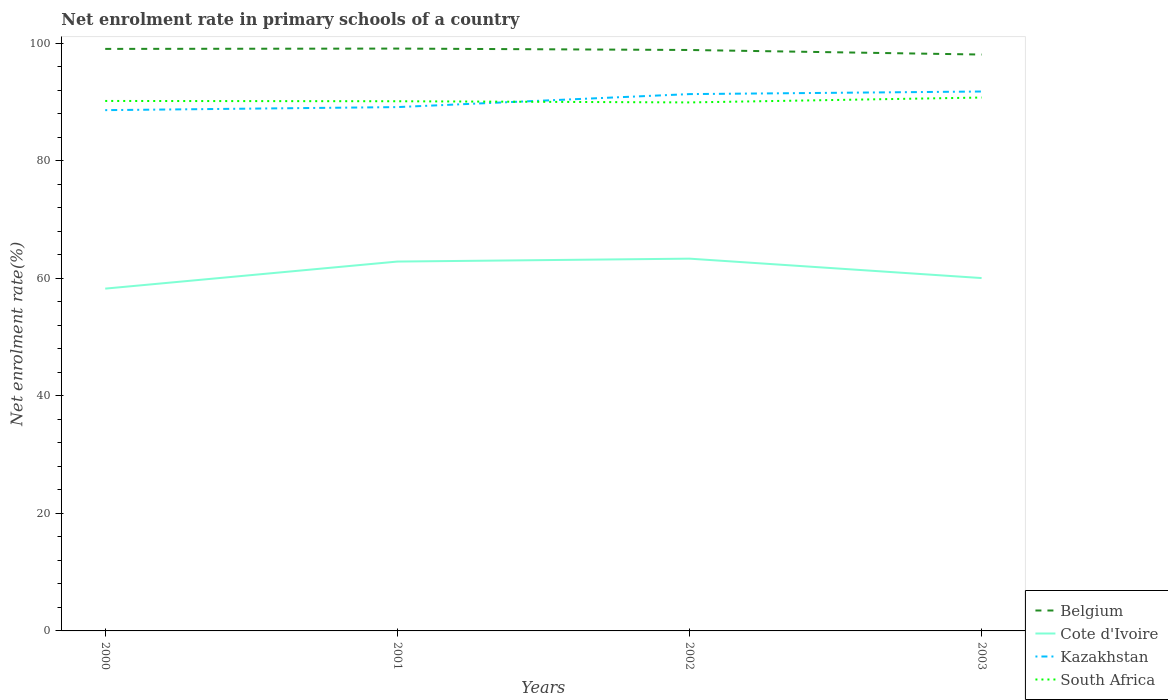How many different coloured lines are there?
Offer a terse response. 4. Is the number of lines equal to the number of legend labels?
Your answer should be compact. Yes. Across all years, what is the maximum net enrolment rate in primary schools in South Africa?
Keep it short and to the point. 89.95. What is the total net enrolment rate in primary schools in Belgium in the graph?
Provide a succinct answer. 0.96. What is the difference between the highest and the second highest net enrolment rate in primary schools in South Africa?
Your answer should be very brief. 0.83. How many years are there in the graph?
Ensure brevity in your answer.  4. Does the graph contain any zero values?
Make the answer very short. No. Does the graph contain grids?
Your answer should be very brief. No. What is the title of the graph?
Keep it short and to the point. Net enrolment rate in primary schools of a country. Does "Burkina Faso" appear as one of the legend labels in the graph?
Ensure brevity in your answer.  No. What is the label or title of the Y-axis?
Keep it short and to the point. Net enrolment rate(%). What is the Net enrolment rate(%) of Belgium in 2000?
Keep it short and to the point. 99.06. What is the Net enrolment rate(%) of Cote d'Ivoire in 2000?
Your answer should be very brief. 58.26. What is the Net enrolment rate(%) in Kazakhstan in 2000?
Offer a very short reply. 88.63. What is the Net enrolment rate(%) of South Africa in 2000?
Provide a short and direct response. 90.2. What is the Net enrolment rate(%) of Belgium in 2001?
Ensure brevity in your answer.  99.11. What is the Net enrolment rate(%) of Cote d'Ivoire in 2001?
Offer a very short reply. 62.86. What is the Net enrolment rate(%) of Kazakhstan in 2001?
Your answer should be very brief. 89.15. What is the Net enrolment rate(%) of South Africa in 2001?
Your answer should be compact. 90.15. What is the Net enrolment rate(%) in Belgium in 2002?
Offer a very short reply. 98.87. What is the Net enrolment rate(%) in Cote d'Ivoire in 2002?
Provide a succinct answer. 63.36. What is the Net enrolment rate(%) of Kazakhstan in 2002?
Give a very brief answer. 91.36. What is the Net enrolment rate(%) of South Africa in 2002?
Ensure brevity in your answer.  89.95. What is the Net enrolment rate(%) of Belgium in 2003?
Keep it short and to the point. 98.09. What is the Net enrolment rate(%) in Cote d'Ivoire in 2003?
Ensure brevity in your answer.  60.05. What is the Net enrolment rate(%) of Kazakhstan in 2003?
Provide a succinct answer. 91.81. What is the Net enrolment rate(%) of South Africa in 2003?
Offer a very short reply. 90.78. Across all years, what is the maximum Net enrolment rate(%) of Belgium?
Ensure brevity in your answer.  99.11. Across all years, what is the maximum Net enrolment rate(%) in Cote d'Ivoire?
Make the answer very short. 63.36. Across all years, what is the maximum Net enrolment rate(%) of Kazakhstan?
Provide a short and direct response. 91.81. Across all years, what is the maximum Net enrolment rate(%) in South Africa?
Your answer should be compact. 90.78. Across all years, what is the minimum Net enrolment rate(%) of Belgium?
Your answer should be compact. 98.09. Across all years, what is the minimum Net enrolment rate(%) in Cote d'Ivoire?
Ensure brevity in your answer.  58.26. Across all years, what is the minimum Net enrolment rate(%) in Kazakhstan?
Your response must be concise. 88.63. Across all years, what is the minimum Net enrolment rate(%) in South Africa?
Give a very brief answer. 89.95. What is the total Net enrolment rate(%) in Belgium in the graph?
Provide a short and direct response. 395.13. What is the total Net enrolment rate(%) of Cote d'Ivoire in the graph?
Provide a short and direct response. 244.53. What is the total Net enrolment rate(%) of Kazakhstan in the graph?
Your answer should be very brief. 360.95. What is the total Net enrolment rate(%) in South Africa in the graph?
Provide a short and direct response. 361.07. What is the difference between the Net enrolment rate(%) of Belgium in 2000 and that in 2001?
Make the answer very short. -0.06. What is the difference between the Net enrolment rate(%) in Cote d'Ivoire in 2000 and that in 2001?
Keep it short and to the point. -4.6. What is the difference between the Net enrolment rate(%) in Kazakhstan in 2000 and that in 2001?
Your answer should be very brief. -0.52. What is the difference between the Net enrolment rate(%) of South Africa in 2000 and that in 2001?
Your response must be concise. 0.05. What is the difference between the Net enrolment rate(%) of Belgium in 2000 and that in 2002?
Offer a terse response. 0.18. What is the difference between the Net enrolment rate(%) in Cote d'Ivoire in 2000 and that in 2002?
Ensure brevity in your answer.  -5.1. What is the difference between the Net enrolment rate(%) in Kazakhstan in 2000 and that in 2002?
Your response must be concise. -2.73. What is the difference between the Net enrolment rate(%) in South Africa in 2000 and that in 2002?
Offer a terse response. 0.25. What is the difference between the Net enrolment rate(%) in Belgium in 2000 and that in 2003?
Ensure brevity in your answer.  0.96. What is the difference between the Net enrolment rate(%) in Cote d'Ivoire in 2000 and that in 2003?
Your answer should be compact. -1.8. What is the difference between the Net enrolment rate(%) in Kazakhstan in 2000 and that in 2003?
Provide a succinct answer. -3.17. What is the difference between the Net enrolment rate(%) in South Africa in 2000 and that in 2003?
Provide a short and direct response. -0.58. What is the difference between the Net enrolment rate(%) in Belgium in 2001 and that in 2002?
Offer a terse response. 0.24. What is the difference between the Net enrolment rate(%) in Cote d'Ivoire in 2001 and that in 2002?
Provide a succinct answer. -0.5. What is the difference between the Net enrolment rate(%) of Kazakhstan in 2001 and that in 2002?
Offer a very short reply. -2.21. What is the difference between the Net enrolment rate(%) of South Africa in 2001 and that in 2002?
Make the answer very short. 0.2. What is the difference between the Net enrolment rate(%) of Belgium in 2001 and that in 2003?
Give a very brief answer. 1.02. What is the difference between the Net enrolment rate(%) of Cote d'Ivoire in 2001 and that in 2003?
Give a very brief answer. 2.81. What is the difference between the Net enrolment rate(%) of Kazakhstan in 2001 and that in 2003?
Provide a short and direct response. -2.65. What is the difference between the Net enrolment rate(%) of South Africa in 2001 and that in 2003?
Your response must be concise. -0.63. What is the difference between the Net enrolment rate(%) in Belgium in 2002 and that in 2003?
Give a very brief answer. 0.78. What is the difference between the Net enrolment rate(%) of Cote d'Ivoire in 2002 and that in 2003?
Offer a terse response. 3.3. What is the difference between the Net enrolment rate(%) in Kazakhstan in 2002 and that in 2003?
Your answer should be compact. -0.44. What is the difference between the Net enrolment rate(%) of South Africa in 2002 and that in 2003?
Ensure brevity in your answer.  -0.83. What is the difference between the Net enrolment rate(%) in Belgium in 2000 and the Net enrolment rate(%) in Cote d'Ivoire in 2001?
Offer a terse response. 36.19. What is the difference between the Net enrolment rate(%) of Belgium in 2000 and the Net enrolment rate(%) of Kazakhstan in 2001?
Ensure brevity in your answer.  9.9. What is the difference between the Net enrolment rate(%) of Belgium in 2000 and the Net enrolment rate(%) of South Africa in 2001?
Make the answer very short. 8.91. What is the difference between the Net enrolment rate(%) of Cote d'Ivoire in 2000 and the Net enrolment rate(%) of Kazakhstan in 2001?
Provide a short and direct response. -30.89. What is the difference between the Net enrolment rate(%) of Cote d'Ivoire in 2000 and the Net enrolment rate(%) of South Africa in 2001?
Ensure brevity in your answer.  -31.89. What is the difference between the Net enrolment rate(%) in Kazakhstan in 2000 and the Net enrolment rate(%) in South Africa in 2001?
Your answer should be very brief. -1.52. What is the difference between the Net enrolment rate(%) of Belgium in 2000 and the Net enrolment rate(%) of Cote d'Ivoire in 2002?
Your answer should be compact. 35.7. What is the difference between the Net enrolment rate(%) in Belgium in 2000 and the Net enrolment rate(%) in Kazakhstan in 2002?
Ensure brevity in your answer.  7.69. What is the difference between the Net enrolment rate(%) in Belgium in 2000 and the Net enrolment rate(%) in South Africa in 2002?
Keep it short and to the point. 9.11. What is the difference between the Net enrolment rate(%) of Cote d'Ivoire in 2000 and the Net enrolment rate(%) of Kazakhstan in 2002?
Your answer should be compact. -33.11. What is the difference between the Net enrolment rate(%) in Cote d'Ivoire in 2000 and the Net enrolment rate(%) in South Africa in 2002?
Ensure brevity in your answer.  -31.69. What is the difference between the Net enrolment rate(%) in Kazakhstan in 2000 and the Net enrolment rate(%) in South Africa in 2002?
Your answer should be compact. -1.31. What is the difference between the Net enrolment rate(%) of Belgium in 2000 and the Net enrolment rate(%) of Cote d'Ivoire in 2003?
Ensure brevity in your answer.  39. What is the difference between the Net enrolment rate(%) in Belgium in 2000 and the Net enrolment rate(%) in Kazakhstan in 2003?
Offer a terse response. 7.25. What is the difference between the Net enrolment rate(%) of Belgium in 2000 and the Net enrolment rate(%) of South Africa in 2003?
Provide a succinct answer. 8.28. What is the difference between the Net enrolment rate(%) of Cote d'Ivoire in 2000 and the Net enrolment rate(%) of Kazakhstan in 2003?
Provide a succinct answer. -33.55. What is the difference between the Net enrolment rate(%) in Cote d'Ivoire in 2000 and the Net enrolment rate(%) in South Africa in 2003?
Make the answer very short. -32.52. What is the difference between the Net enrolment rate(%) of Kazakhstan in 2000 and the Net enrolment rate(%) of South Africa in 2003?
Your answer should be very brief. -2.15. What is the difference between the Net enrolment rate(%) of Belgium in 2001 and the Net enrolment rate(%) of Cote d'Ivoire in 2002?
Your answer should be compact. 35.75. What is the difference between the Net enrolment rate(%) in Belgium in 2001 and the Net enrolment rate(%) in Kazakhstan in 2002?
Provide a short and direct response. 7.75. What is the difference between the Net enrolment rate(%) of Belgium in 2001 and the Net enrolment rate(%) of South Africa in 2002?
Give a very brief answer. 9.16. What is the difference between the Net enrolment rate(%) of Cote d'Ivoire in 2001 and the Net enrolment rate(%) of Kazakhstan in 2002?
Provide a succinct answer. -28.5. What is the difference between the Net enrolment rate(%) of Cote d'Ivoire in 2001 and the Net enrolment rate(%) of South Africa in 2002?
Your answer should be very brief. -27.08. What is the difference between the Net enrolment rate(%) in Kazakhstan in 2001 and the Net enrolment rate(%) in South Africa in 2002?
Your answer should be compact. -0.8. What is the difference between the Net enrolment rate(%) in Belgium in 2001 and the Net enrolment rate(%) in Cote d'Ivoire in 2003?
Keep it short and to the point. 39.06. What is the difference between the Net enrolment rate(%) of Belgium in 2001 and the Net enrolment rate(%) of Kazakhstan in 2003?
Your answer should be very brief. 7.31. What is the difference between the Net enrolment rate(%) of Belgium in 2001 and the Net enrolment rate(%) of South Africa in 2003?
Keep it short and to the point. 8.33. What is the difference between the Net enrolment rate(%) of Cote d'Ivoire in 2001 and the Net enrolment rate(%) of Kazakhstan in 2003?
Provide a succinct answer. -28.94. What is the difference between the Net enrolment rate(%) in Cote d'Ivoire in 2001 and the Net enrolment rate(%) in South Africa in 2003?
Offer a terse response. -27.92. What is the difference between the Net enrolment rate(%) of Kazakhstan in 2001 and the Net enrolment rate(%) of South Africa in 2003?
Keep it short and to the point. -1.63. What is the difference between the Net enrolment rate(%) of Belgium in 2002 and the Net enrolment rate(%) of Cote d'Ivoire in 2003?
Your response must be concise. 38.82. What is the difference between the Net enrolment rate(%) in Belgium in 2002 and the Net enrolment rate(%) in Kazakhstan in 2003?
Offer a terse response. 7.07. What is the difference between the Net enrolment rate(%) in Belgium in 2002 and the Net enrolment rate(%) in South Africa in 2003?
Give a very brief answer. 8.09. What is the difference between the Net enrolment rate(%) in Cote d'Ivoire in 2002 and the Net enrolment rate(%) in Kazakhstan in 2003?
Give a very brief answer. -28.45. What is the difference between the Net enrolment rate(%) in Cote d'Ivoire in 2002 and the Net enrolment rate(%) in South Africa in 2003?
Your answer should be very brief. -27.42. What is the difference between the Net enrolment rate(%) of Kazakhstan in 2002 and the Net enrolment rate(%) of South Africa in 2003?
Make the answer very short. 0.59. What is the average Net enrolment rate(%) in Belgium per year?
Offer a very short reply. 98.78. What is the average Net enrolment rate(%) of Cote d'Ivoire per year?
Keep it short and to the point. 61.13. What is the average Net enrolment rate(%) in Kazakhstan per year?
Give a very brief answer. 90.24. What is the average Net enrolment rate(%) in South Africa per year?
Offer a terse response. 90.27. In the year 2000, what is the difference between the Net enrolment rate(%) in Belgium and Net enrolment rate(%) in Cote d'Ivoire?
Your answer should be very brief. 40.8. In the year 2000, what is the difference between the Net enrolment rate(%) in Belgium and Net enrolment rate(%) in Kazakhstan?
Your answer should be compact. 10.42. In the year 2000, what is the difference between the Net enrolment rate(%) in Belgium and Net enrolment rate(%) in South Africa?
Provide a succinct answer. 8.86. In the year 2000, what is the difference between the Net enrolment rate(%) in Cote d'Ivoire and Net enrolment rate(%) in Kazakhstan?
Your response must be concise. -30.38. In the year 2000, what is the difference between the Net enrolment rate(%) in Cote d'Ivoire and Net enrolment rate(%) in South Africa?
Offer a very short reply. -31.94. In the year 2000, what is the difference between the Net enrolment rate(%) in Kazakhstan and Net enrolment rate(%) in South Africa?
Provide a succinct answer. -1.56. In the year 2001, what is the difference between the Net enrolment rate(%) of Belgium and Net enrolment rate(%) of Cote d'Ivoire?
Ensure brevity in your answer.  36.25. In the year 2001, what is the difference between the Net enrolment rate(%) in Belgium and Net enrolment rate(%) in Kazakhstan?
Offer a terse response. 9.96. In the year 2001, what is the difference between the Net enrolment rate(%) in Belgium and Net enrolment rate(%) in South Africa?
Your answer should be very brief. 8.96. In the year 2001, what is the difference between the Net enrolment rate(%) in Cote d'Ivoire and Net enrolment rate(%) in Kazakhstan?
Give a very brief answer. -26.29. In the year 2001, what is the difference between the Net enrolment rate(%) in Cote d'Ivoire and Net enrolment rate(%) in South Africa?
Give a very brief answer. -27.29. In the year 2001, what is the difference between the Net enrolment rate(%) of Kazakhstan and Net enrolment rate(%) of South Africa?
Give a very brief answer. -1. In the year 2002, what is the difference between the Net enrolment rate(%) of Belgium and Net enrolment rate(%) of Cote d'Ivoire?
Your response must be concise. 35.51. In the year 2002, what is the difference between the Net enrolment rate(%) of Belgium and Net enrolment rate(%) of Kazakhstan?
Offer a terse response. 7.51. In the year 2002, what is the difference between the Net enrolment rate(%) in Belgium and Net enrolment rate(%) in South Africa?
Provide a short and direct response. 8.93. In the year 2002, what is the difference between the Net enrolment rate(%) in Cote d'Ivoire and Net enrolment rate(%) in Kazakhstan?
Ensure brevity in your answer.  -28.01. In the year 2002, what is the difference between the Net enrolment rate(%) in Cote d'Ivoire and Net enrolment rate(%) in South Africa?
Keep it short and to the point. -26.59. In the year 2002, what is the difference between the Net enrolment rate(%) of Kazakhstan and Net enrolment rate(%) of South Africa?
Offer a very short reply. 1.42. In the year 2003, what is the difference between the Net enrolment rate(%) in Belgium and Net enrolment rate(%) in Cote d'Ivoire?
Ensure brevity in your answer.  38.04. In the year 2003, what is the difference between the Net enrolment rate(%) in Belgium and Net enrolment rate(%) in Kazakhstan?
Offer a very short reply. 6.29. In the year 2003, what is the difference between the Net enrolment rate(%) in Belgium and Net enrolment rate(%) in South Africa?
Your answer should be compact. 7.32. In the year 2003, what is the difference between the Net enrolment rate(%) in Cote d'Ivoire and Net enrolment rate(%) in Kazakhstan?
Keep it short and to the point. -31.75. In the year 2003, what is the difference between the Net enrolment rate(%) of Cote d'Ivoire and Net enrolment rate(%) of South Africa?
Offer a very short reply. -30.72. In the year 2003, what is the difference between the Net enrolment rate(%) in Kazakhstan and Net enrolment rate(%) in South Africa?
Give a very brief answer. 1.03. What is the ratio of the Net enrolment rate(%) of Belgium in 2000 to that in 2001?
Provide a succinct answer. 1. What is the ratio of the Net enrolment rate(%) of Cote d'Ivoire in 2000 to that in 2001?
Make the answer very short. 0.93. What is the ratio of the Net enrolment rate(%) in Kazakhstan in 2000 to that in 2001?
Make the answer very short. 0.99. What is the ratio of the Net enrolment rate(%) of South Africa in 2000 to that in 2001?
Offer a very short reply. 1. What is the ratio of the Net enrolment rate(%) in Belgium in 2000 to that in 2002?
Your answer should be compact. 1. What is the ratio of the Net enrolment rate(%) of Cote d'Ivoire in 2000 to that in 2002?
Your answer should be very brief. 0.92. What is the ratio of the Net enrolment rate(%) in Kazakhstan in 2000 to that in 2002?
Keep it short and to the point. 0.97. What is the ratio of the Net enrolment rate(%) of Belgium in 2000 to that in 2003?
Offer a very short reply. 1.01. What is the ratio of the Net enrolment rate(%) of Cote d'Ivoire in 2000 to that in 2003?
Provide a short and direct response. 0.97. What is the ratio of the Net enrolment rate(%) of Kazakhstan in 2000 to that in 2003?
Keep it short and to the point. 0.97. What is the ratio of the Net enrolment rate(%) of South Africa in 2000 to that in 2003?
Provide a succinct answer. 0.99. What is the ratio of the Net enrolment rate(%) of Belgium in 2001 to that in 2002?
Your answer should be compact. 1. What is the ratio of the Net enrolment rate(%) of Kazakhstan in 2001 to that in 2002?
Provide a short and direct response. 0.98. What is the ratio of the Net enrolment rate(%) in South Africa in 2001 to that in 2002?
Give a very brief answer. 1. What is the ratio of the Net enrolment rate(%) of Belgium in 2001 to that in 2003?
Ensure brevity in your answer.  1.01. What is the ratio of the Net enrolment rate(%) in Cote d'Ivoire in 2001 to that in 2003?
Offer a terse response. 1.05. What is the ratio of the Net enrolment rate(%) in Kazakhstan in 2001 to that in 2003?
Provide a short and direct response. 0.97. What is the ratio of the Net enrolment rate(%) of South Africa in 2001 to that in 2003?
Your response must be concise. 0.99. What is the ratio of the Net enrolment rate(%) in Belgium in 2002 to that in 2003?
Provide a short and direct response. 1.01. What is the ratio of the Net enrolment rate(%) in Cote d'Ivoire in 2002 to that in 2003?
Provide a succinct answer. 1.05. What is the difference between the highest and the second highest Net enrolment rate(%) of Belgium?
Keep it short and to the point. 0.06. What is the difference between the highest and the second highest Net enrolment rate(%) of Cote d'Ivoire?
Give a very brief answer. 0.5. What is the difference between the highest and the second highest Net enrolment rate(%) of Kazakhstan?
Provide a short and direct response. 0.44. What is the difference between the highest and the second highest Net enrolment rate(%) of South Africa?
Make the answer very short. 0.58. What is the difference between the highest and the lowest Net enrolment rate(%) of Belgium?
Provide a short and direct response. 1.02. What is the difference between the highest and the lowest Net enrolment rate(%) of Cote d'Ivoire?
Keep it short and to the point. 5.1. What is the difference between the highest and the lowest Net enrolment rate(%) in Kazakhstan?
Provide a succinct answer. 3.17. What is the difference between the highest and the lowest Net enrolment rate(%) of South Africa?
Your response must be concise. 0.83. 